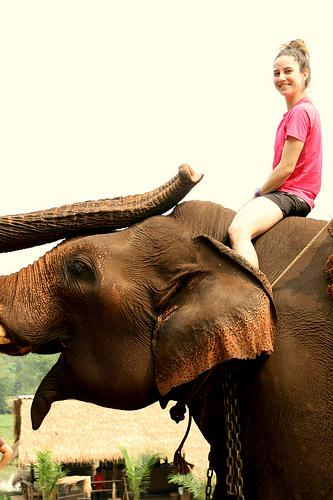Question: what type of animal is shown?
Choices:
A. Pig.
B. Antelope.
C. Tiger.
D. Elephant.
Answer with the letter. Answer: D Question: what color shorts is the girl wearing?
Choices:
A. Red.
B. Brown.
C. Gray.
D. Blue.
Answer with the letter. Answer: B Question: what is hanging from the elephant?
Choices:
A. Trunk.
B. Paint brush.
C. Chains.
D. Ears.
Answer with the letter. Answer: C Question: where was the photo taken?
Choices:
A. Casino.
B. Bar.
C. Hospital.
D. In a zoo.
Answer with the letter. Answer: D Question: what color shirt is the girl wearing?
Choices:
A. Pink.
B. Red.
C. White.
D. Black.
Answer with the letter. Answer: A Question: what color is the rope?
Choices:
A. White.
B. Black.
C. Tan.
D. Red.
Answer with the letter. Answer: D 